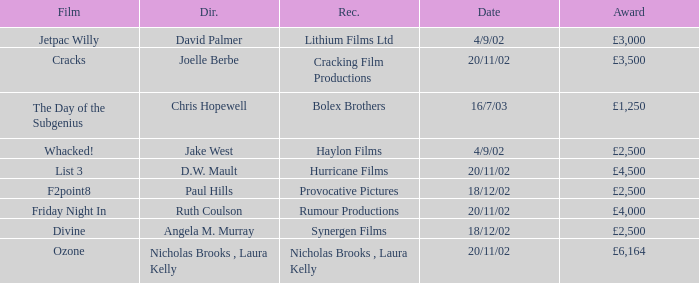Who won an award of £3,000 on 4/9/02? Lithium Films Ltd. 